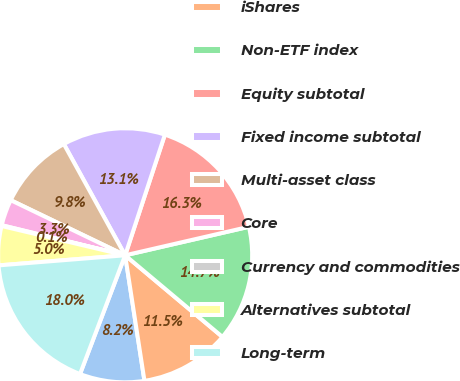Convert chart to OTSL. <chart><loc_0><loc_0><loc_500><loc_500><pie_chart><fcel>Active<fcel>iShares<fcel>Non-ETF index<fcel>Equity subtotal<fcel>Fixed income subtotal<fcel>Multi-asset class<fcel>Core<fcel>Currency and commodities<fcel>Alternatives subtotal<fcel>Long-term<nl><fcel>8.21%<fcel>11.46%<fcel>14.71%<fcel>16.33%<fcel>13.08%<fcel>9.84%<fcel>3.34%<fcel>0.1%<fcel>4.97%<fcel>17.95%<nl></chart> 